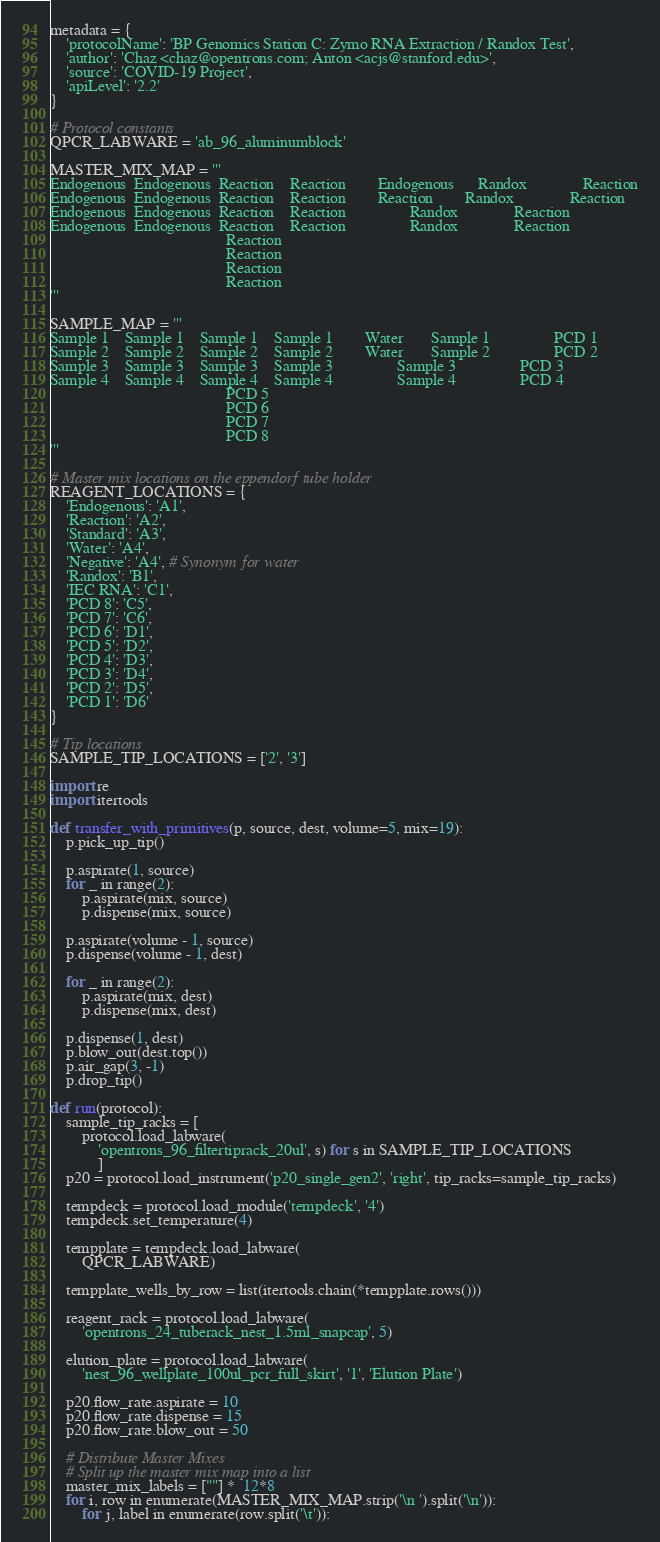<code> <loc_0><loc_0><loc_500><loc_500><_Python_>metadata = {
    'protocolName': 'BP Genomics Station C: Zymo RNA Extraction / Randox Test',
    'author': 'Chaz <chaz@opentrons.com; Anton <acjs@stanford.edu>',
    'source': 'COVID-19 Project',
    'apiLevel': '2.2'
}

# Protocol constants
QPCR_LABWARE = 'ab_96_aluminumblock'

MASTER_MIX_MAP = '''
Endogenous	Endogenous	Reaction	Reaction		Endogenous		Randox				Reaction
Endogenous	Endogenous	Reaction	Reaction		Reaction		Randox				Reaction
Endogenous	Endogenous	Reaction	Reaction				Randox				Reaction
Endogenous	Endogenous	Reaction	Reaction				Randox				Reaction
											Reaction
											Reaction
											Reaction
											Reaction
'''

SAMPLE_MAP = '''
Sample 1	Sample 1	Sample 1	Sample 1		Water		Sample 1				PCD 1
Sample 2	Sample 2	Sample 2	Sample 2		Water		Sample 2				PCD 2
Sample 3	Sample 3	Sample 3	Sample 3				Sample 3				PCD 3
Sample 4	Sample 4	Sample 4	Sample 4				Sample 4				PCD 4
											PCD 5
											PCD 6
											PCD 7
											PCD 8
'''

# Master mix locations on the eppendorf tube holder
REAGENT_LOCATIONS = {
    'Endogenous': 'A1',
    'Reaction': 'A2',
    'Standard': 'A3',
    'Water': 'A4',
    'Negative': 'A4', # Synonym for water
    'Randox': 'B1',
    'IEC RNA': 'C1',
    'PCD 8': 'C5',
    'PCD 7': 'C6',
    'PCD 6': 'D1',
    'PCD 5': 'D2',
    'PCD 4': 'D3',
    'PCD 3': 'D4',
    'PCD 2': 'D5',
    'PCD 1': 'D6'
}

# Tip locations
SAMPLE_TIP_LOCATIONS = ['2', '3']

import re
import itertools

def transfer_with_primitives(p, source, dest, volume=5, mix=19):
    p.pick_up_tip()

    p.aspirate(1, source)
    for _ in range(2):
        p.aspirate(mix, source)
        p.dispense(mix, source)

    p.aspirate(volume - 1, source)
    p.dispense(volume - 1, dest)

    for _ in range(2):
        p.aspirate(mix, dest)
        p.dispense(mix, dest)

    p.dispense(1, dest)
    p.blow_out(dest.top())
    p.air_gap(3, -1)
    p.drop_tip()

def run(protocol):
    sample_tip_racks = [
        protocol.load_labware(
            'opentrons_96_filtertiprack_20ul', s) for s in SAMPLE_TIP_LOCATIONS
            ]
    p20 = protocol.load_instrument('p20_single_gen2', 'right', tip_racks=sample_tip_racks)

    tempdeck = protocol.load_module('tempdeck', '4')
    tempdeck.set_temperature(4)

    tempplate = tempdeck.load_labware(
        QPCR_LABWARE)

    tempplate_wells_by_row = list(itertools.chain(*tempplate.rows()))

    reagent_rack = protocol.load_labware(
        'opentrons_24_tuberack_nest_1.5ml_snapcap', 5)

    elution_plate = protocol.load_labware(
        'nest_96_wellplate_100ul_pcr_full_skirt', '1', 'Elution Plate')

    p20.flow_rate.aspirate = 10
    p20.flow_rate.dispense = 15
    p20.flow_rate.blow_out = 50

    # Distribute Master Mixes
    # Split up the master mix map into a list
    master_mix_labels = [""] *  12*8
    for i, row in enumerate(MASTER_MIX_MAP.strip('\n ').split('\n')):
        for j, label in enumerate(row.split('\t')):</code> 